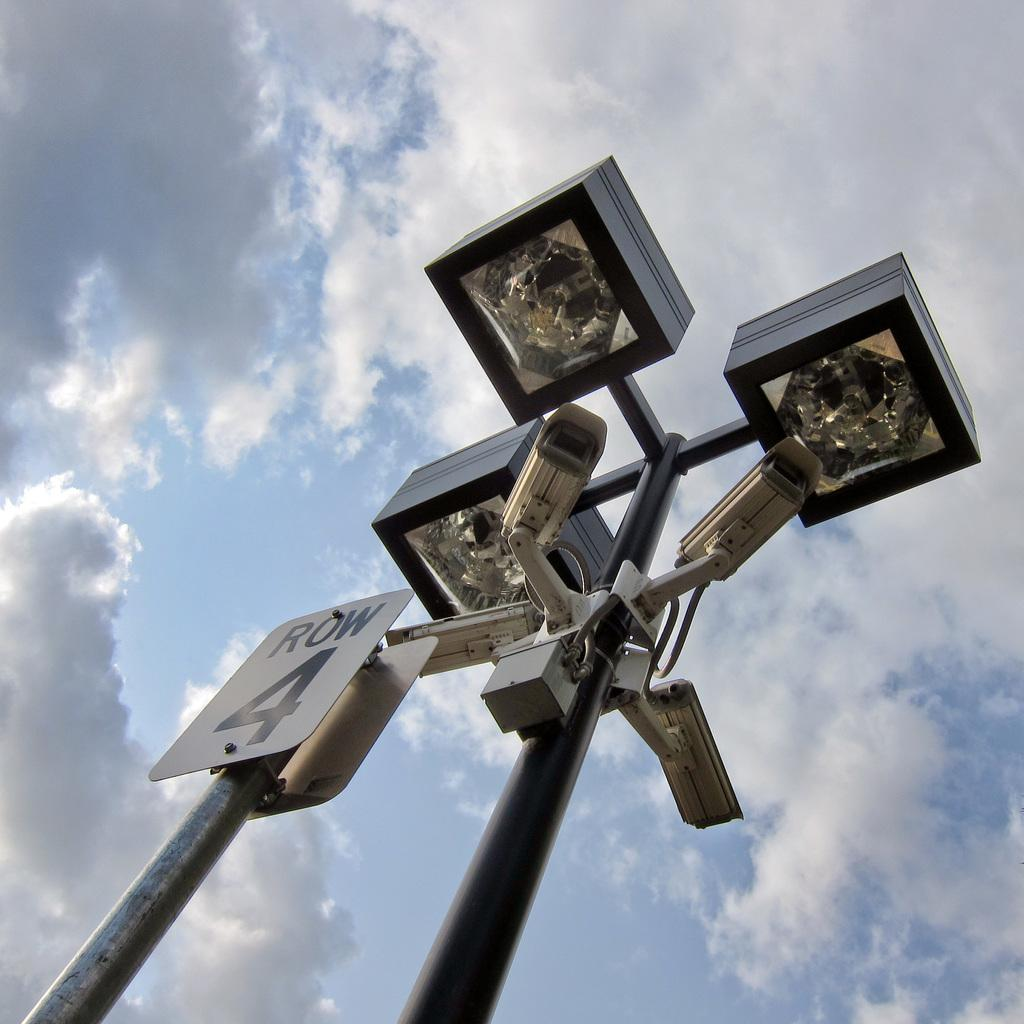What structures are present in the image? There are poles in the image. What else can be seen in the image besides the poles? There is a board, lights, cameras, and a box in the image. What might be used to capture images in the image? The cameras in the image might be used to capture images. What is visible in the background of the image? The sky is visible in the background of the image. What type of pin can be seen holding a memory in the image? There is no pin or memory present in the image. What meal is being prepared in the image? There is no meal being prepared in the image. 